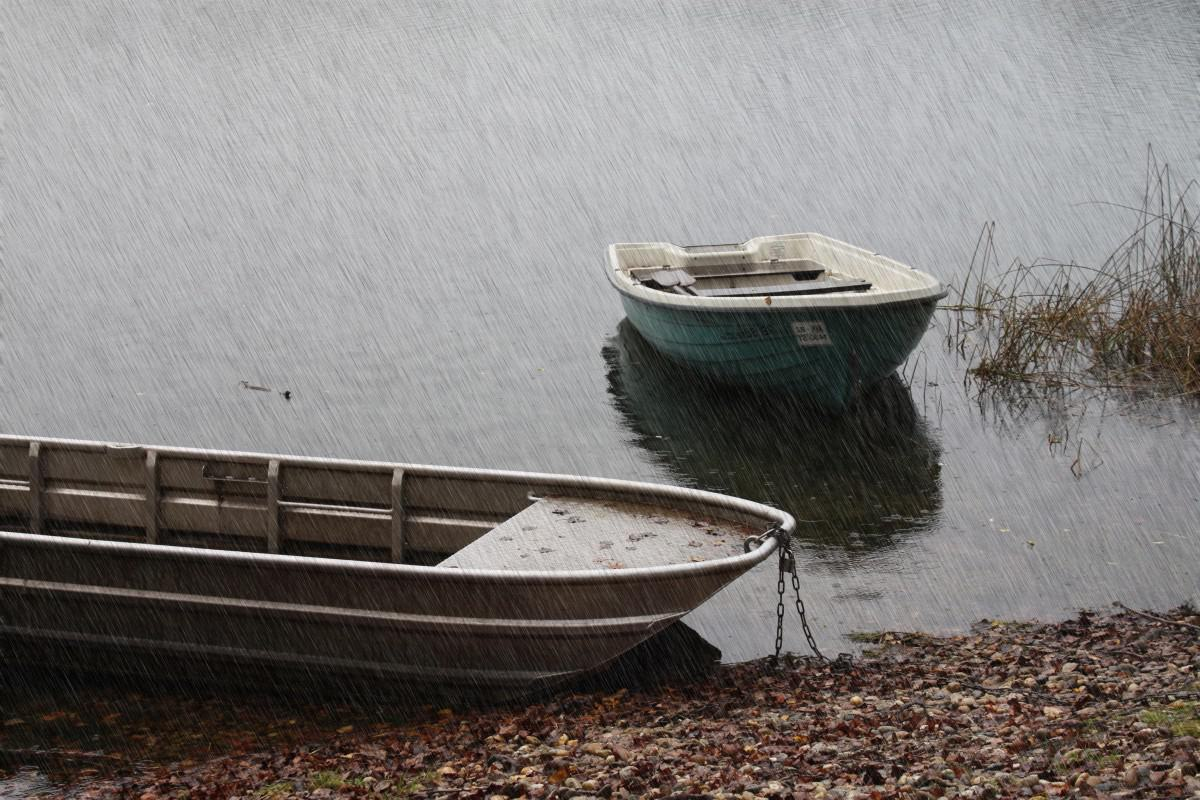What's the weather like in the image? The weather in the image appears to be quite gloomy and rainy. You can observe the heavy raindrops hitting the surface of the lake and the overall overcast atmosphere. 